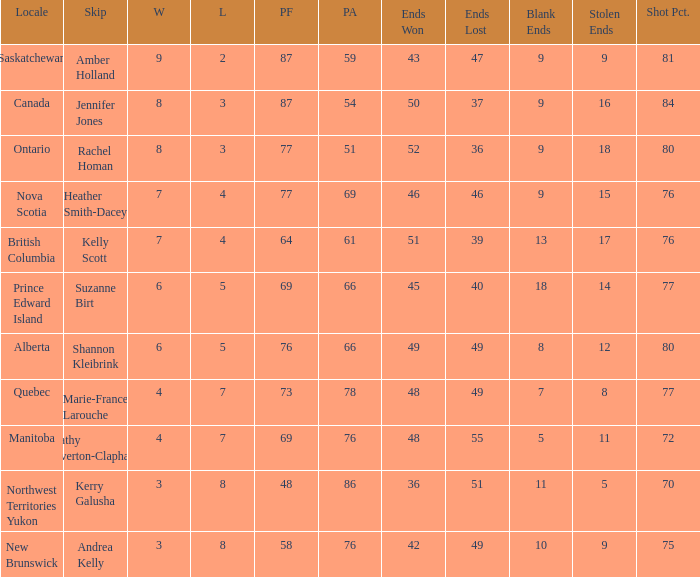If the locale is Ontario, what is the W minimum? 8.0. Write the full table. {'header': ['Locale', 'Skip', 'W', 'L', 'PF', 'PA', 'Ends Won', 'Ends Lost', 'Blank Ends', 'Stolen Ends', 'Shot Pct.'], 'rows': [['Saskatchewan', 'Amber Holland', '9', '2', '87', '59', '43', '47', '9', '9', '81'], ['Canada', 'Jennifer Jones', '8', '3', '87', '54', '50', '37', '9', '16', '84'], ['Ontario', 'Rachel Homan', '8', '3', '77', '51', '52', '36', '9', '18', '80'], ['Nova Scotia', 'Heather Smith-Dacey', '7', '4', '77', '69', '46', '46', '9', '15', '76'], ['British Columbia', 'Kelly Scott', '7', '4', '64', '61', '51', '39', '13', '17', '76'], ['Prince Edward Island', 'Suzanne Birt', '6', '5', '69', '66', '45', '40', '18', '14', '77'], ['Alberta', 'Shannon Kleibrink', '6', '5', '76', '66', '49', '49', '8', '12', '80'], ['Quebec', 'Marie-France Larouche', '4', '7', '73', '78', '48', '49', '7', '8', '77'], ['Manitoba', 'Cathy Overton-Clapham', '4', '7', '69', '76', '48', '55', '5', '11', '72'], ['Northwest Territories Yukon', 'Kerry Galusha', '3', '8', '48', '86', '36', '51', '11', '5', '70'], ['New Brunswick', 'Andrea Kelly', '3', '8', '58', '76', '42', '49', '10', '9', '75']]} 